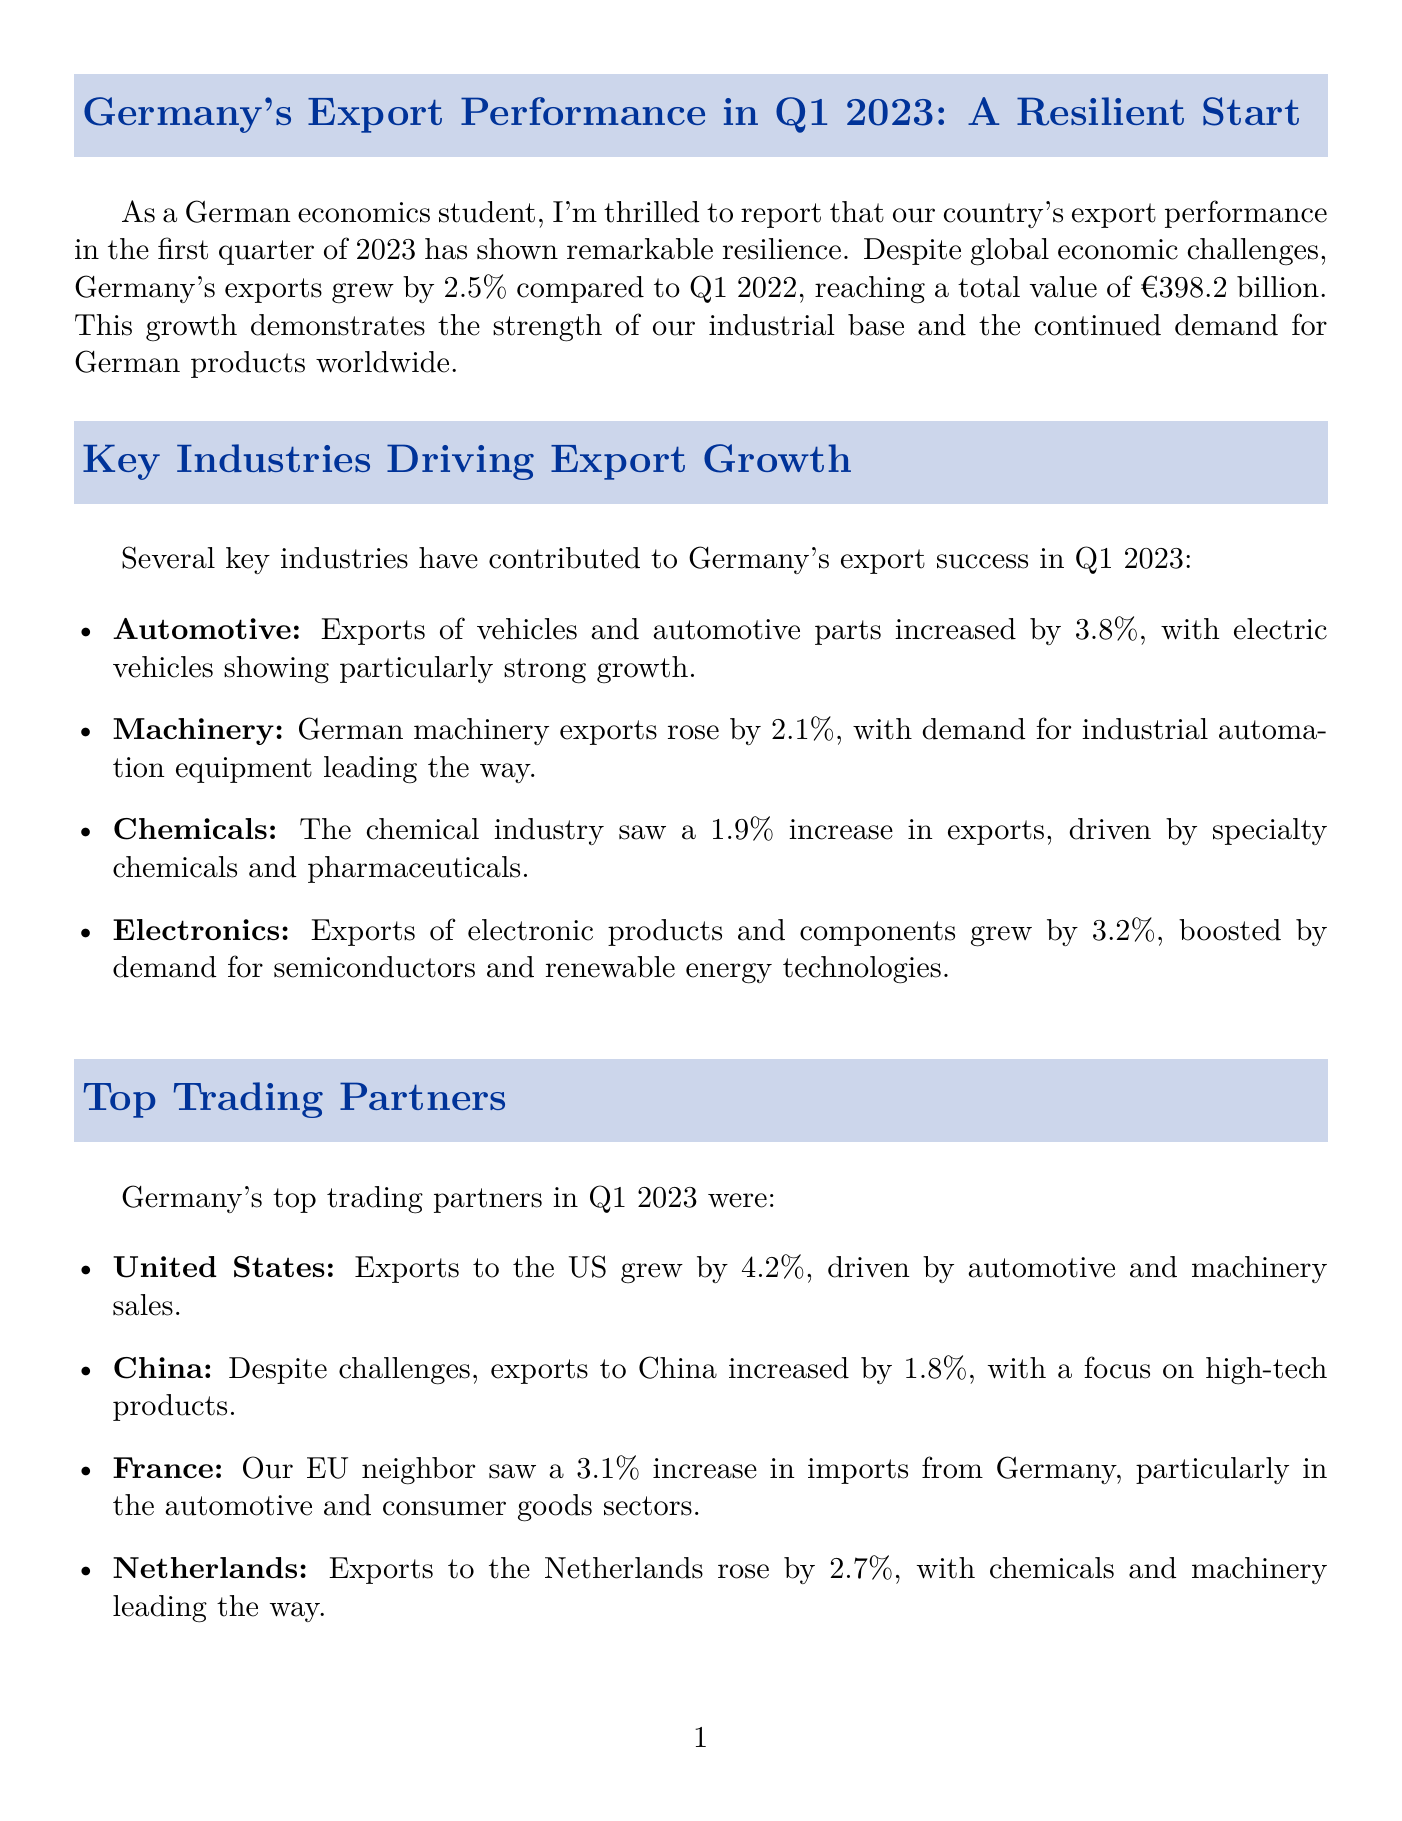What was the growth rate of Germany's exports in Q1 2023? The document states that Germany's exports grew by 2.5% in Q1 2023 compared to Q1 2022.
Answer: 2.5% What is the total export value for Q1 2023? The document specifies that the total export value reached €398.2 billion in Q1 2023.
Answer: €398.2 billion Which sector had the highest export growth in Q1 2023? The document indicates that the automotive sector had the highest export growth at 3.8%.
Answer: Automotive: 3.8% Who was Germany's fastest-growing export market in Q1 2023? The document mentions that exports to the United States grew by 4.2%, making it the fastest-growing market.
Answer: United States: 4.2% What are the main challenges mentioned for Germany's exports? The document lists supply chain disruptions, energy costs, and geopolitical tensions as ongoing challenges.
Answer: Supply chain disruptions, energy costs, geopolitical tensions In which sector did exports increase by 1.9%? The document states that the chemical industry saw a 1.9% increase in exports.
Answer: Chemicals: 1.9% Which country experienced a growth of 3.1% in imports from Germany? The document specifies that France saw a 3.1% increase in imports from Germany.
Answer: France: 3.1% What strategy has the German government announced to strengthen exports? The document discusses the 'Export Strategy 2030' aimed at diversifying trading partnerships.
Answer: Export Strategy 2030 Who provided a quote about Germany's export performance? The document attributes the quote to Dr. Claudia Buch, Vice-President of the Deutsche Bundesbank.
Answer: Dr. Claudia Buch 